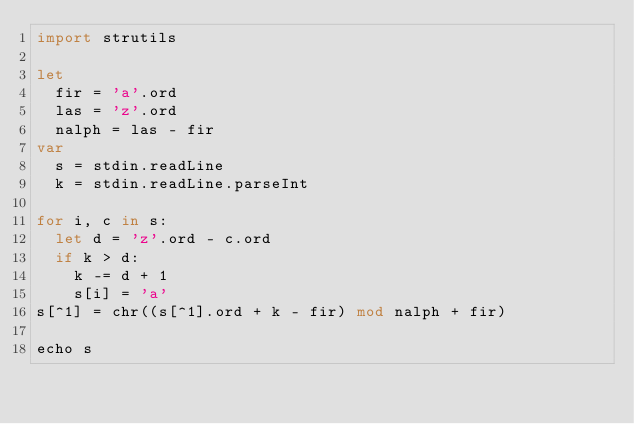<code> <loc_0><loc_0><loc_500><loc_500><_Nim_>import strutils

let
  fir = 'a'.ord
  las = 'z'.ord
  nalph = las - fir
var
  s = stdin.readLine
  k = stdin.readLine.parseInt

for i, c in s:
  let d = 'z'.ord - c.ord
  if k > d:
    k -= d + 1
    s[i] = 'a'
s[^1] = chr((s[^1].ord + k - fir) mod nalph + fir)

echo s</code> 